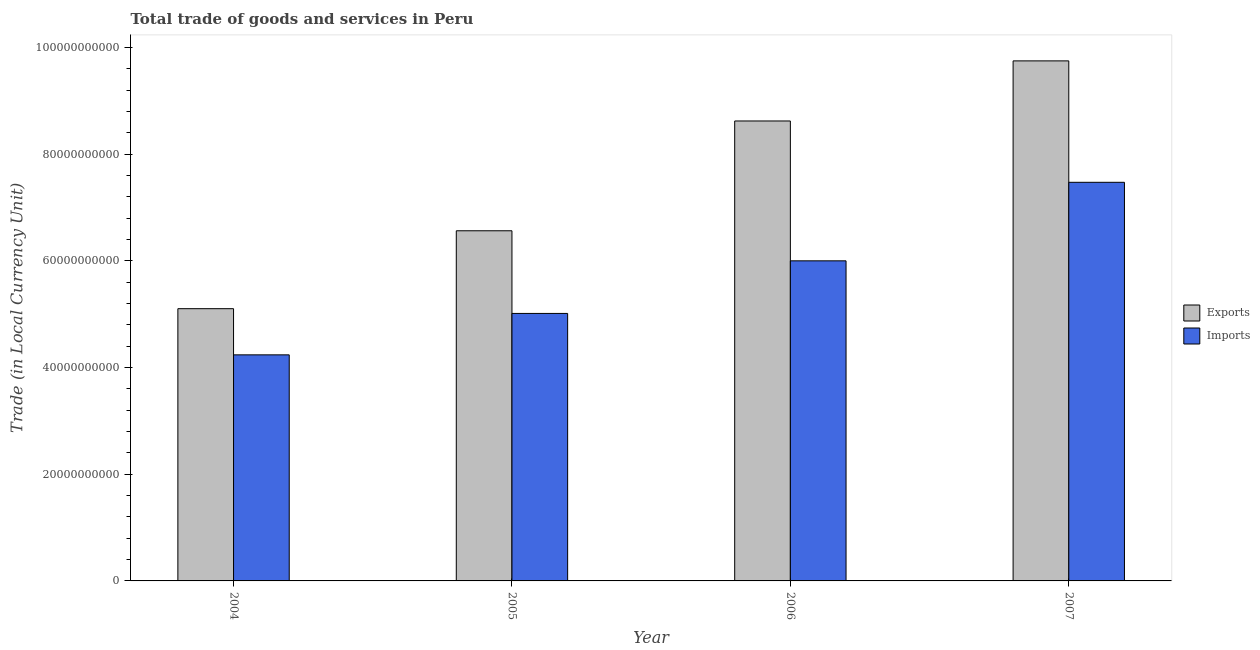How many different coloured bars are there?
Your answer should be very brief. 2. How many groups of bars are there?
Offer a very short reply. 4. Are the number of bars on each tick of the X-axis equal?
Your answer should be very brief. Yes. How many bars are there on the 3rd tick from the left?
Offer a very short reply. 2. How many bars are there on the 2nd tick from the right?
Give a very brief answer. 2. What is the imports of goods and services in 2007?
Keep it short and to the point. 7.47e+1. Across all years, what is the maximum export of goods and services?
Give a very brief answer. 9.75e+1. Across all years, what is the minimum export of goods and services?
Provide a short and direct response. 5.10e+1. In which year was the export of goods and services maximum?
Ensure brevity in your answer.  2007. What is the total imports of goods and services in the graph?
Provide a succinct answer. 2.27e+11. What is the difference between the export of goods and services in 2005 and that in 2006?
Provide a succinct answer. -2.06e+1. What is the difference between the export of goods and services in 2006 and the imports of goods and services in 2007?
Give a very brief answer. -1.13e+1. What is the average export of goods and services per year?
Your response must be concise. 7.51e+1. In the year 2005, what is the difference between the imports of goods and services and export of goods and services?
Ensure brevity in your answer.  0. In how many years, is the export of goods and services greater than 8000000000 LCU?
Offer a terse response. 4. What is the ratio of the imports of goods and services in 2004 to that in 2007?
Provide a short and direct response. 0.57. Is the export of goods and services in 2005 less than that in 2007?
Ensure brevity in your answer.  Yes. What is the difference between the highest and the second highest imports of goods and services?
Offer a terse response. 1.47e+1. What is the difference between the highest and the lowest imports of goods and services?
Your answer should be compact. 3.24e+1. What does the 1st bar from the left in 2004 represents?
Your answer should be compact. Exports. What does the 2nd bar from the right in 2005 represents?
Ensure brevity in your answer.  Exports. Are all the bars in the graph horizontal?
Keep it short and to the point. No. How many years are there in the graph?
Keep it short and to the point. 4. Does the graph contain any zero values?
Ensure brevity in your answer.  No. Does the graph contain grids?
Make the answer very short. No. Where does the legend appear in the graph?
Your response must be concise. Center right. How are the legend labels stacked?
Your answer should be compact. Vertical. What is the title of the graph?
Provide a short and direct response. Total trade of goods and services in Peru. Does "Sanitation services" appear as one of the legend labels in the graph?
Give a very brief answer. No. What is the label or title of the Y-axis?
Ensure brevity in your answer.  Trade (in Local Currency Unit). What is the Trade (in Local Currency Unit) of Exports in 2004?
Your response must be concise. 5.10e+1. What is the Trade (in Local Currency Unit) of Imports in 2004?
Ensure brevity in your answer.  4.24e+1. What is the Trade (in Local Currency Unit) in Exports in 2005?
Offer a very short reply. 6.56e+1. What is the Trade (in Local Currency Unit) of Imports in 2005?
Offer a very short reply. 5.02e+1. What is the Trade (in Local Currency Unit) in Exports in 2006?
Keep it short and to the point. 8.62e+1. What is the Trade (in Local Currency Unit) in Imports in 2006?
Keep it short and to the point. 6.00e+1. What is the Trade (in Local Currency Unit) in Exports in 2007?
Make the answer very short. 9.75e+1. What is the Trade (in Local Currency Unit) of Imports in 2007?
Your response must be concise. 7.47e+1. Across all years, what is the maximum Trade (in Local Currency Unit) of Exports?
Provide a short and direct response. 9.75e+1. Across all years, what is the maximum Trade (in Local Currency Unit) in Imports?
Ensure brevity in your answer.  7.47e+1. Across all years, what is the minimum Trade (in Local Currency Unit) in Exports?
Provide a short and direct response. 5.10e+1. Across all years, what is the minimum Trade (in Local Currency Unit) of Imports?
Your answer should be very brief. 4.24e+1. What is the total Trade (in Local Currency Unit) in Exports in the graph?
Your response must be concise. 3.00e+11. What is the total Trade (in Local Currency Unit) in Imports in the graph?
Provide a succinct answer. 2.27e+11. What is the difference between the Trade (in Local Currency Unit) of Exports in 2004 and that in 2005?
Offer a very short reply. -1.46e+1. What is the difference between the Trade (in Local Currency Unit) of Imports in 2004 and that in 2005?
Your answer should be very brief. -7.77e+09. What is the difference between the Trade (in Local Currency Unit) of Exports in 2004 and that in 2006?
Keep it short and to the point. -3.52e+1. What is the difference between the Trade (in Local Currency Unit) in Imports in 2004 and that in 2006?
Make the answer very short. -1.76e+1. What is the difference between the Trade (in Local Currency Unit) of Exports in 2004 and that in 2007?
Your answer should be very brief. -4.65e+1. What is the difference between the Trade (in Local Currency Unit) of Imports in 2004 and that in 2007?
Offer a terse response. -3.24e+1. What is the difference between the Trade (in Local Currency Unit) of Exports in 2005 and that in 2006?
Keep it short and to the point. -2.06e+1. What is the difference between the Trade (in Local Currency Unit) of Imports in 2005 and that in 2006?
Provide a succinct answer. -9.86e+09. What is the difference between the Trade (in Local Currency Unit) in Exports in 2005 and that in 2007?
Your response must be concise. -3.19e+1. What is the difference between the Trade (in Local Currency Unit) of Imports in 2005 and that in 2007?
Offer a terse response. -2.46e+1. What is the difference between the Trade (in Local Currency Unit) of Exports in 2006 and that in 2007?
Ensure brevity in your answer.  -1.13e+1. What is the difference between the Trade (in Local Currency Unit) of Imports in 2006 and that in 2007?
Your response must be concise. -1.47e+1. What is the difference between the Trade (in Local Currency Unit) of Exports in 2004 and the Trade (in Local Currency Unit) of Imports in 2005?
Make the answer very short. 8.90e+08. What is the difference between the Trade (in Local Currency Unit) in Exports in 2004 and the Trade (in Local Currency Unit) in Imports in 2006?
Offer a terse response. -8.97e+09. What is the difference between the Trade (in Local Currency Unit) of Exports in 2004 and the Trade (in Local Currency Unit) of Imports in 2007?
Keep it short and to the point. -2.37e+1. What is the difference between the Trade (in Local Currency Unit) in Exports in 2005 and the Trade (in Local Currency Unit) in Imports in 2006?
Keep it short and to the point. 5.63e+09. What is the difference between the Trade (in Local Currency Unit) in Exports in 2005 and the Trade (in Local Currency Unit) in Imports in 2007?
Offer a terse response. -9.09e+09. What is the difference between the Trade (in Local Currency Unit) in Exports in 2006 and the Trade (in Local Currency Unit) in Imports in 2007?
Your answer should be very brief. 1.15e+1. What is the average Trade (in Local Currency Unit) in Exports per year?
Ensure brevity in your answer.  7.51e+1. What is the average Trade (in Local Currency Unit) of Imports per year?
Make the answer very short. 5.68e+1. In the year 2004, what is the difference between the Trade (in Local Currency Unit) in Exports and Trade (in Local Currency Unit) in Imports?
Your answer should be very brief. 8.66e+09. In the year 2005, what is the difference between the Trade (in Local Currency Unit) of Exports and Trade (in Local Currency Unit) of Imports?
Your answer should be compact. 1.55e+1. In the year 2006, what is the difference between the Trade (in Local Currency Unit) in Exports and Trade (in Local Currency Unit) in Imports?
Offer a terse response. 2.62e+1. In the year 2007, what is the difference between the Trade (in Local Currency Unit) of Exports and Trade (in Local Currency Unit) of Imports?
Give a very brief answer. 2.28e+1. What is the ratio of the Trade (in Local Currency Unit) in Exports in 2004 to that in 2005?
Your answer should be compact. 0.78. What is the ratio of the Trade (in Local Currency Unit) in Imports in 2004 to that in 2005?
Your response must be concise. 0.85. What is the ratio of the Trade (in Local Currency Unit) in Exports in 2004 to that in 2006?
Give a very brief answer. 0.59. What is the ratio of the Trade (in Local Currency Unit) in Imports in 2004 to that in 2006?
Your answer should be compact. 0.71. What is the ratio of the Trade (in Local Currency Unit) in Exports in 2004 to that in 2007?
Your answer should be very brief. 0.52. What is the ratio of the Trade (in Local Currency Unit) of Imports in 2004 to that in 2007?
Offer a terse response. 0.57. What is the ratio of the Trade (in Local Currency Unit) of Exports in 2005 to that in 2006?
Offer a terse response. 0.76. What is the ratio of the Trade (in Local Currency Unit) of Imports in 2005 to that in 2006?
Your answer should be compact. 0.84. What is the ratio of the Trade (in Local Currency Unit) in Exports in 2005 to that in 2007?
Offer a terse response. 0.67. What is the ratio of the Trade (in Local Currency Unit) in Imports in 2005 to that in 2007?
Keep it short and to the point. 0.67. What is the ratio of the Trade (in Local Currency Unit) in Exports in 2006 to that in 2007?
Ensure brevity in your answer.  0.88. What is the ratio of the Trade (in Local Currency Unit) of Imports in 2006 to that in 2007?
Provide a succinct answer. 0.8. What is the difference between the highest and the second highest Trade (in Local Currency Unit) in Exports?
Your answer should be very brief. 1.13e+1. What is the difference between the highest and the second highest Trade (in Local Currency Unit) of Imports?
Provide a short and direct response. 1.47e+1. What is the difference between the highest and the lowest Trade (in Local Currency Unit) in Exports?
Make the answer very short. 4.65e+1. What is the difference between the highest and the lowest Trade (in Local Currency Unit) of Imports?
Your answer should be compact. 3.24e+1. 